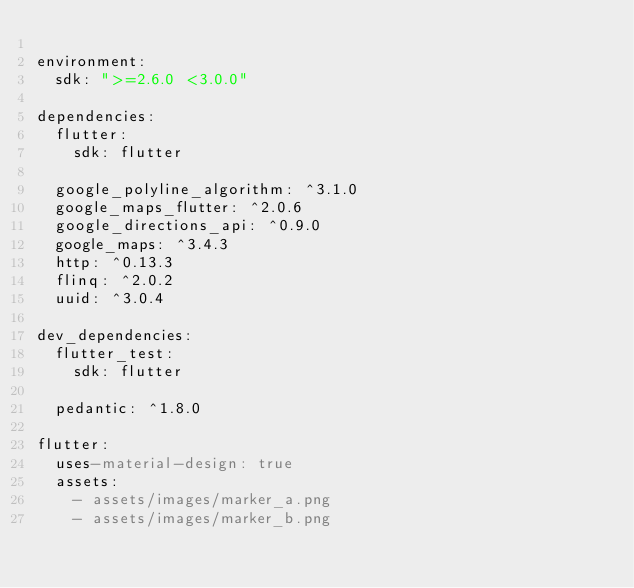Convert code to text. <code><loc_0><loc_0><loc_500><loc_500><_YAML_>
environment:
  sdk: ">=2.6.0 <3.0.0"

dependencies:
  flutter:
    sdk: flutter

  google_polyline_algorithm: ^3.1.0
  google_maps_flutter: ^2.0.6
  google_directions_api: ^0.9.0
  google_maps: ^3.4.3
  http: ^0.13.3
  flinq: ^2.0.2
  uuid: ^3.0.4

dev_dependencies:
  flutter_test:
    sdk: flutter

  pedantic: ^1.8.0

flutter:
  uses-material-design: true
  assets:
    - assets/images/marker_a.png
    - assets/images/marker_b.png
</code> 